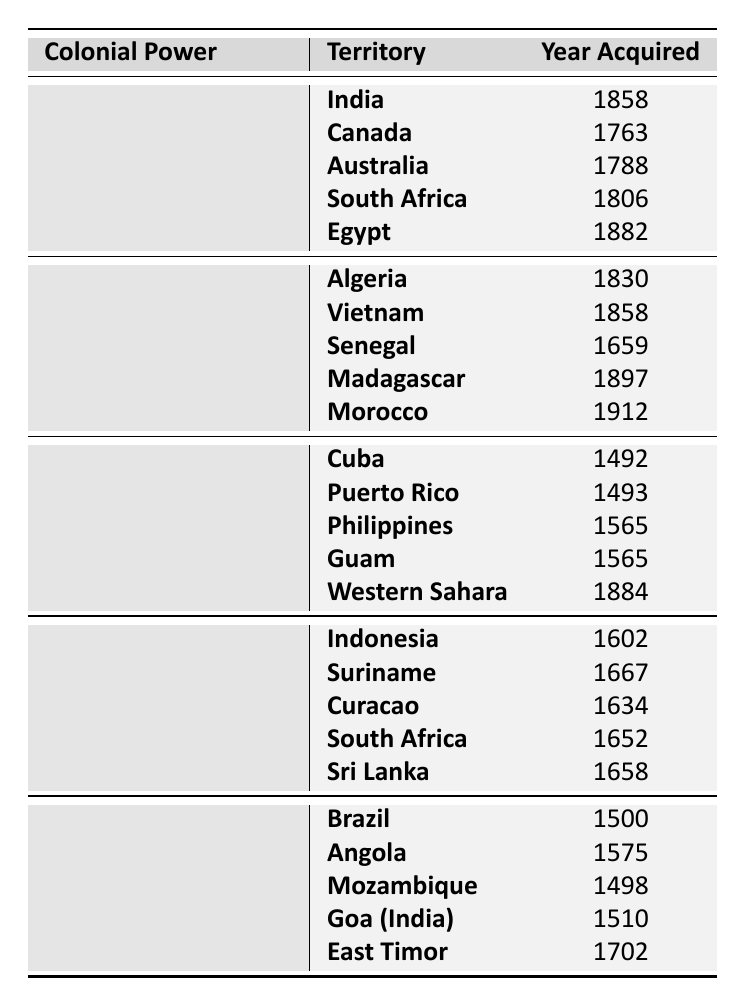What is the territory acquired by the British Empire in 1763? By examining the rows under the British Empire, we see that Canada was recorded as the territory acquired in the year 1763.
Answer: Canada Which colonial power acquired territory in 1492? Looking at the Spanish Empire section, we can identify that Cuba was acquired in the year 1492.
Answer: Spanish Empire Name one territory acquired by the Dutch Empire in the 17th century. In the Dutch Empire section, the territories Indonesia (1602), Suriname (1667), Curacao (1634), South Africa (1652), and Sri Lanka (1658) were acquired in the 17th century. One of them is South Africa, acquired in 1652.
Answer: South Africa True or False: The French Third Republic acquired Morocco before Algeria. The table indicates that Algeria was acquired in 1830 and Morocco in 1912, thus proving the statement false because Algeria was acquired first.
Answer: False How many territories did the Spanish Empire acquire before the year 1700? The Spanish Empire acquired Cuba (1492), Puerto Rico (1493), and the Philippines (1565) before 1700, totaling three territories.
Answer: 3 What is the average year of acquisition for territories under the Portuguese Empire? The years for territories acquired by the Portuguese Empire are 1500, 1575, 1498, 1510, and 1702. Adding these years gives a total of 7450. Dividing by 5 (the number of territories) results in an average year of 1490.
Answer: 1490 Which colonial power has the most recent territory acquisition listed in the table? The most recent year listed is 1912 under the French Third Republic for Morocco, making it the most recent territory acquisition.
Answer: French Third Republic How many territories did the British Empire acquire before the 19th century? The territories acquired by the British Empire before the 19th century are Canada (1763), Australia (1788), and South Africa (1806). This equals three territories.
Answer: 3 Can you find two territories acquired by the Dutch Empire? The table lists several territories acquired by the Dutch Empire, such as Indonesia (1602) and Sri Lanka (1658). Therefore, two of those are Indonesia and Sri Lanka.
Answer: Indonesia, Sri Lanka Which territories acquired by the Portuguese Empire had years in the 1500s? The territories Angola (1575), Mozambique (1498), and Goa (1510) were all acquired in the 1500s. The territories that specifically had years in the 1500s are Angola and Goa.
Answer: Angola, Goa 